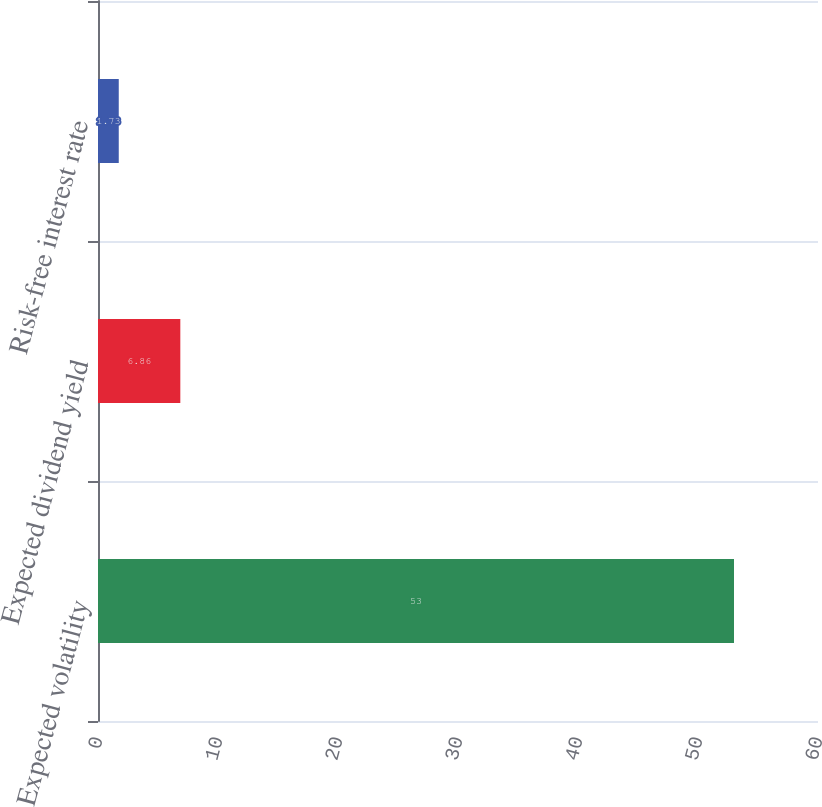<chart> <loc_0><loc_0><loc_500><loc_500><bar_chart><fcel>Expected volatility<fcel>Expected dividend yield<fcel>Risk-free interest rate<nl><fcel>53<fcel>6.86<fcel>1.73<nl></chart> 